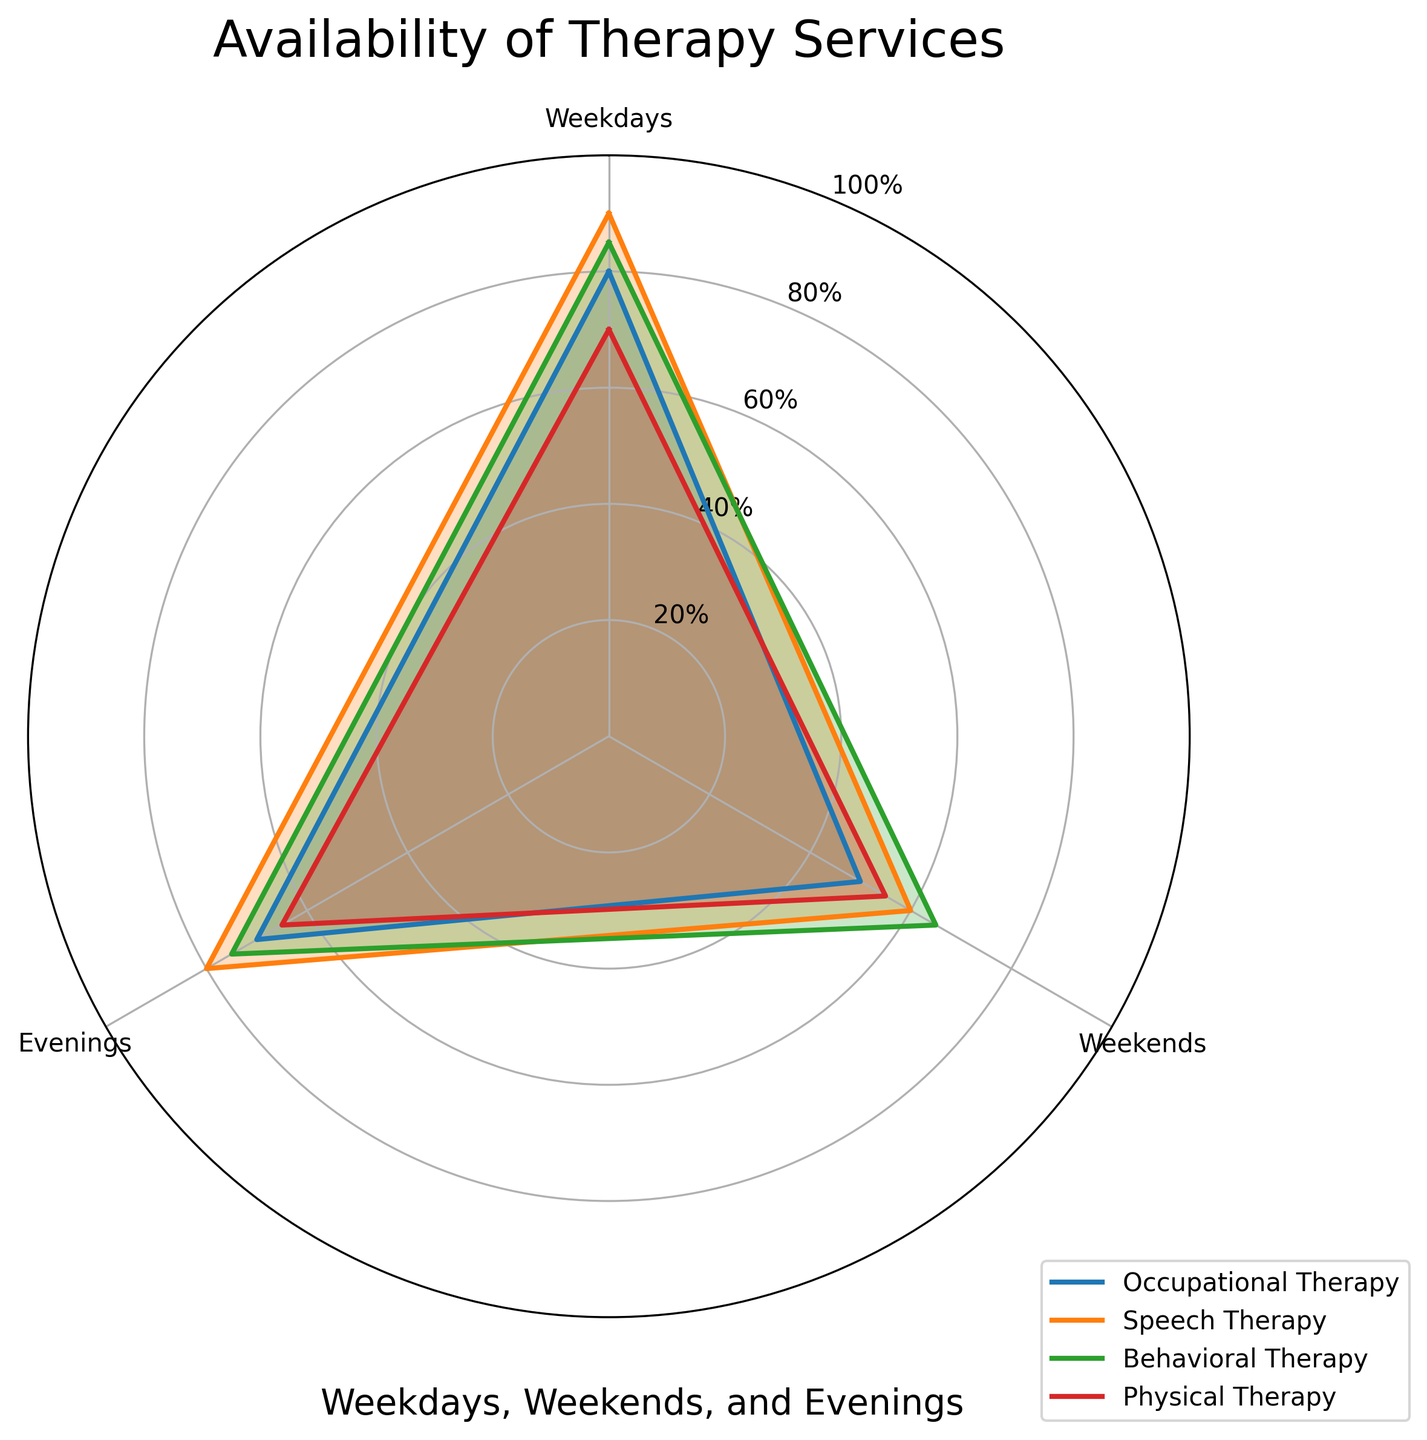What is the title of the radar chart? The title of the radar chart is located at the top and it provides an overview of what the chart represents.
Answer: Availability of Therapy Services How many therapy services are plotted on the radar chart? By counting the distinct lines or labels in the legend, we can determine the number of therapy services displayed.
Answer: Four Which therapy service has the highest availability on weekdays? Look at the value indicated by the weekdays axis for each therapy service. The longest line along the weekdays direction will indicate the service with the highest availability.
Answer: Speech Therapy What is the average availability across all services for weekends? First, find the weekend values for all services: 50 (Occupational Therapy), 60 (Speech Therapy), 65 (Behavioral Therapy), 55 (Physical Therapy). Add these values together and divide by the number of services.
Answer: 57.5% Between Speech Therapy and Physical Therapy, which has better availability in the evenings? Compare the values for evenings between Speech Therapy and Physical Therapy.
Answer: Speech Therapy Which therapy service shows the most evenly distributed availability across all times (weekdays, weekends, evenings)? Determine the service whose availability values are most consistent across all three categories. This requires inspecting the plotted lines to see which service's line is the smoothest (least variance).
Answer: Behavioral Therapy Is there a therapy service that has greater availability on weekdays compared to weekends and evenings combined? Compare the weekday value against the combined average of weekend and evening values for each service. Check if the weekday value is higher.
Answer: No What is the difference in availability on weekends between Behavioral Therapy and Occupational Therapy? Subtract the weekend availability value of Occupational Therapy from that of Behavioral Therapy.
Answer: 65% - 50% = 15% Which service has the lowest availability in the evenings and what is that value? Identify the value for evenings in the radar chart, and find the minimum among these values. This corresponds to the therapy service with the lowest availability.
Answer: Physical Therapy, 65% Considering all time slots (weekdays, weekends, evenings), which therapy service has the highest average availability? Calculate the average availability for each service across the three categories, then find the maximum value among these averages.
Answer: Speech Therapy 